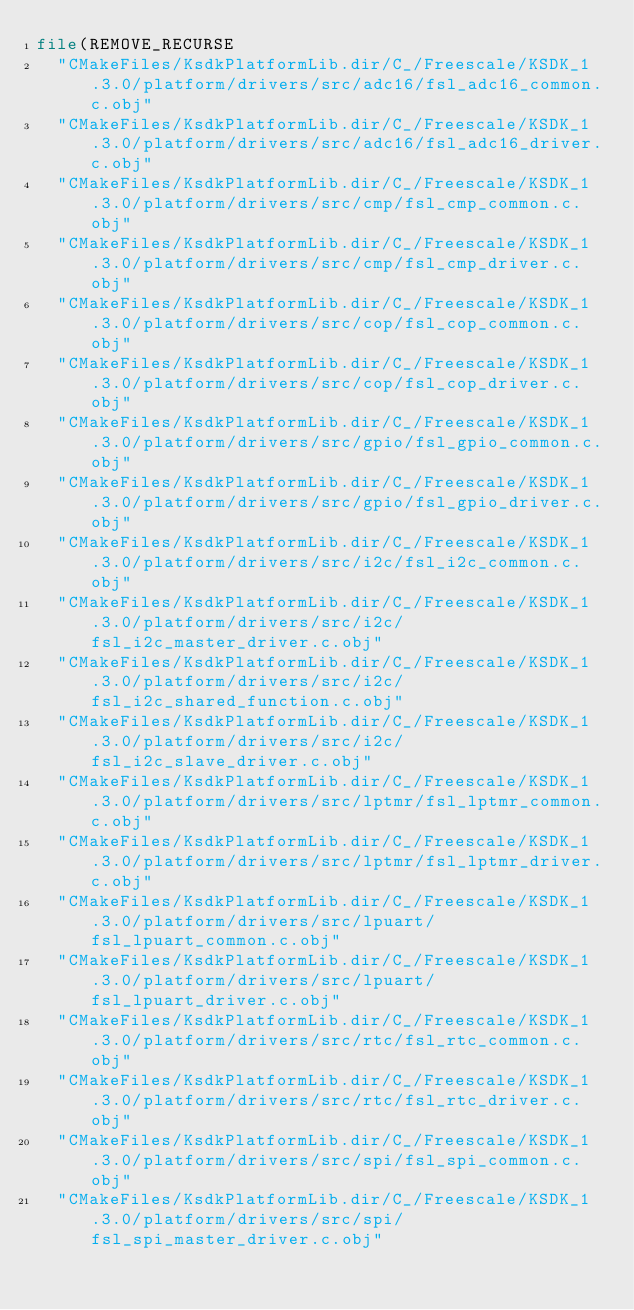<code> <loc_0><loc_0><loc_500><loc_500><_CMake_>file(REMOVE_RECURSE
  "CMakeFiles/KsdkPlatformLib.dir/C_/Freescale/KSDK_1.3.0/platform/drivers/src/adc16/fsl_adc16_common.c.obj"
  "CMakeFiles/KsdkPlatformLib.dir/C_/Freescale/KSDK_1.3.0/platform/drivers/src/adc16/fsl_adc16_driver.c.obj"
  "CMakeFiles/KsdkPlatformLib.dir/C_/Freescale/KSDK_1.3.0/platform/drivers/src/cmp/fsl_cmp_common.c.obj"
  "CMakeFiles/KsdkPlatformLib.dir/C_/Freescale/KSDK_1.3.0/platform/drivers/src/cmp/fsl_cmp_driver.c.obj"
  "CMakeFiles/KsdkPlatformLib.dir/C_/Freescale/KSDK_1.3.0/platform/drivers/src/cop/fsl_cop_common.c.obj"
  "CMakeFiles/KsdkPlatformLib.dir/C_/Freescale/KSDK_1.3.0/platform/drivers/src/cop/fsl_cop_driver.c.obj"
  "CMakeFiles/KsdkPlatformLib.dir/C_/Freescale/KSDK_1.3.0/platform/drivers/src/gpio/fsl_gpio_common.c.obj"
  "CMakeFiles/KsdkPlatformLib.dir/C_/Freescale/KSDK_1.3.0/platform/drivers/src/gpio/fsl_gpio_driver.c.obj"
  "CMakeFiles/KsdkPlatformLib.dir/C_/Freescale/KSDK_1.3.0/platform/drivers/src/i2c/fsl_i2c_common.c.obj"
  "CMakeFiles/KsdkPlatformLib.dir/C_/Freescale/KSDK_1.3.0/platform/drivers/src/i2c/fsl_i2c_master_driver.c.obj"
  "CMakeFiles/KsdkPlatformLib.dir/C_/Freescale/KSDK_1.3.0/platform/drivers/src/i2c/fsl_i2c_shared_function.c.obj"
  "CMakeFiles/KsdkPlatformLib.dir/C_/Freescale/KSDK_1.3.0/platform/drivers/src/i2c/fsl_i2c_slave_driver.c.obj"
  "CMakeFiles/KsdkPlatformLib.dir/C_/Freescale/KSDK_1.3.0/platform/drivers/src/lptmr/fsl_lptmr_common.c.obj"
  "CMakeFiles/KsdkPlatformLib.dir/C_/Freescale/KSDK_1.3.0/platform/drivers/src/lptmr/fsl_lptmr_driver.c.obj"
  "CMakeFiles/KsdkPlatformLib.dir/C_/Freescale/KSDK_1.3.0/platform/drivers/src/lpuart/fsl_lpuart_common.c.obj"
  "CMakeFiles/KsdkPlatformLib.dir/C_/Freescale/KSDK_1.3.0/platform/drivers/src/lpuart/fsl_lpuart_driver.c.obj"
  "CMakeFiles/KsdkPlatformLib.dir/C_/Freescale/KSDK_1.3.0/platform/drivers/src/rtc/fsl_rtc_common.c.obj"
  "CMakeFiles/KsdkPlatformLib.dir/C_/Freescale/KSDK_1.3.0/platform/drivers/src/rtc/fsl_rtc_driver.c.obj"
  "CMakeFiles/KsdkPlatformLib.dir/C_/Freescale/KSDK_1.3.0/platform/drivers/src/spi/fsl_spi_common.c.obj"
  "CMakeFiles/KsdkPlatformLib.dir/C_/Freescale/KSDK_1.3.0/platform/drivers/src/spi/fsl_spi_master_driver.c.obj"</code> 